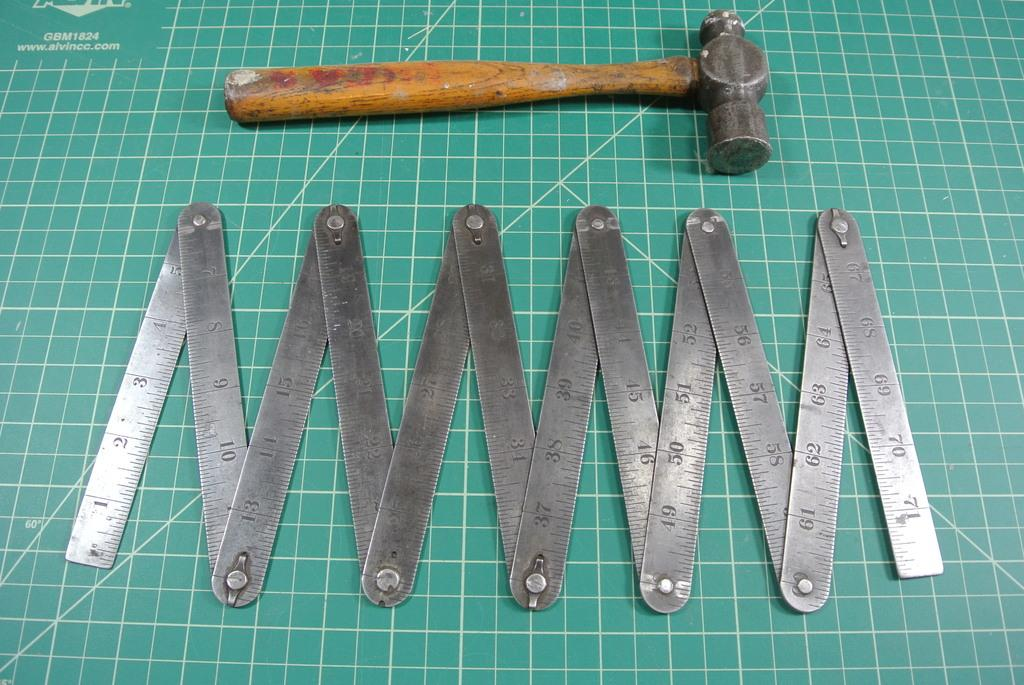<image>
Provide a brief description of the given image. A ball-pin hammer and a folding ruler are on a green grid from alvincc.com. 